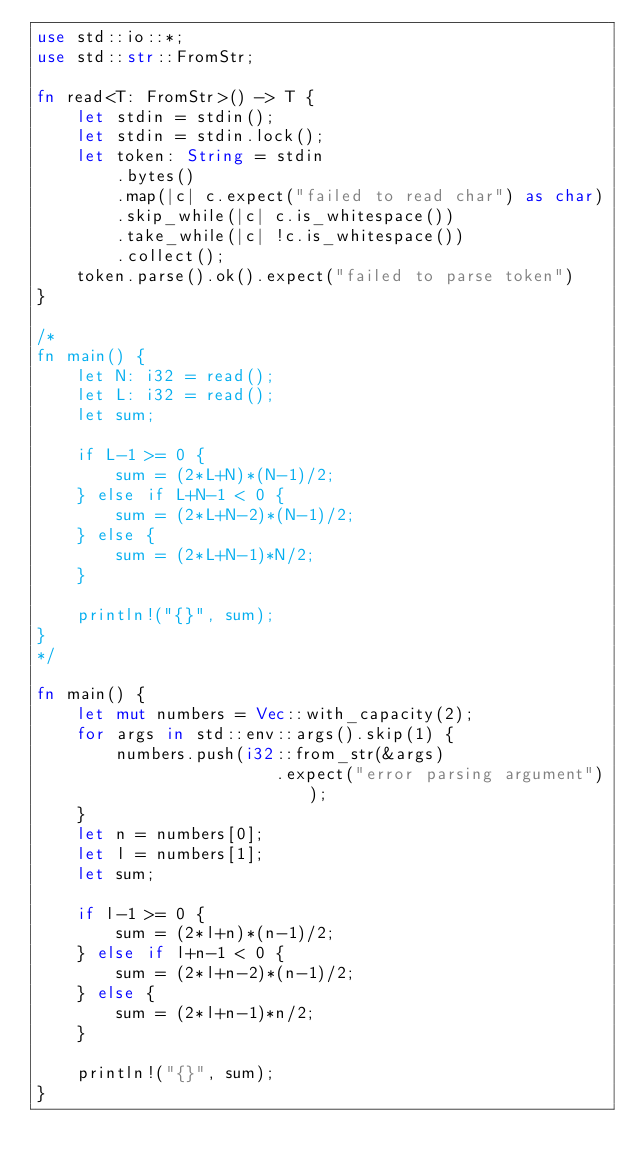Convert code to text. <code><loc_0><loc_0><loc_500><loc_500><_Rust_>use std::io::*;
use std::str::FromStr;

fn read<T: FromStr>() -> T {
    let stdin = stdin();
    let stdin = stdin.lock();
    let token: String = stdin
        .bytes()
        .map(|c| c.expect("failed to read char") as char) 
        .skip_while(|c| c.is_whitespace())
        .take_while(|c| !c.is_whitespace())
        .collect();
    token.parse().ok().expect("failed to parse token")
}

/*
fn main() {
    let N: i32 = read();
    let L: i32 = read();
    let sum;

    if L-1 >= 0 {
        sum = (2*L+N)*(N-1)/2;
    } else if L+N-1 < 0 {
        sum = (2*L+N-2)*(N-1)/2;
    } else {
        sum = (2*L+N-1)*N/2;
    }

    println!("{}", sum);
}
*/

fn main() {
    let mut numbers = Vec::with_capacity(2);
    for args in std::env::args().skip(1) {
        numbers.push(i32::from_str(&args)
                        .expect("error parsing argument"));   
    }
    let n = numbers[0];
    let l = numbers[1];
    let sum;

    if l-1 >= 0 {
        sum = (2*l+n)*(n-1)/2;
    } else if l+n-1 < 0 {
        sum = (2*l+n-2)*(n-1)/2;
    } else {
        sum = (2*l+n-1)*n/2;
    }

    println!("{}", sum);
}</code> 